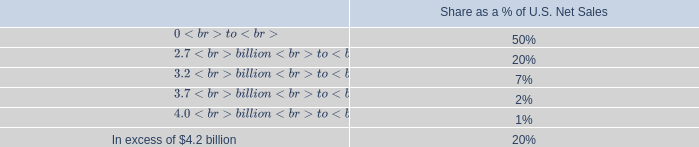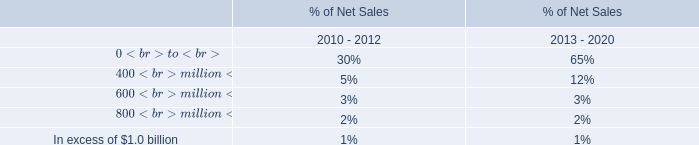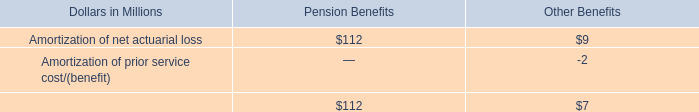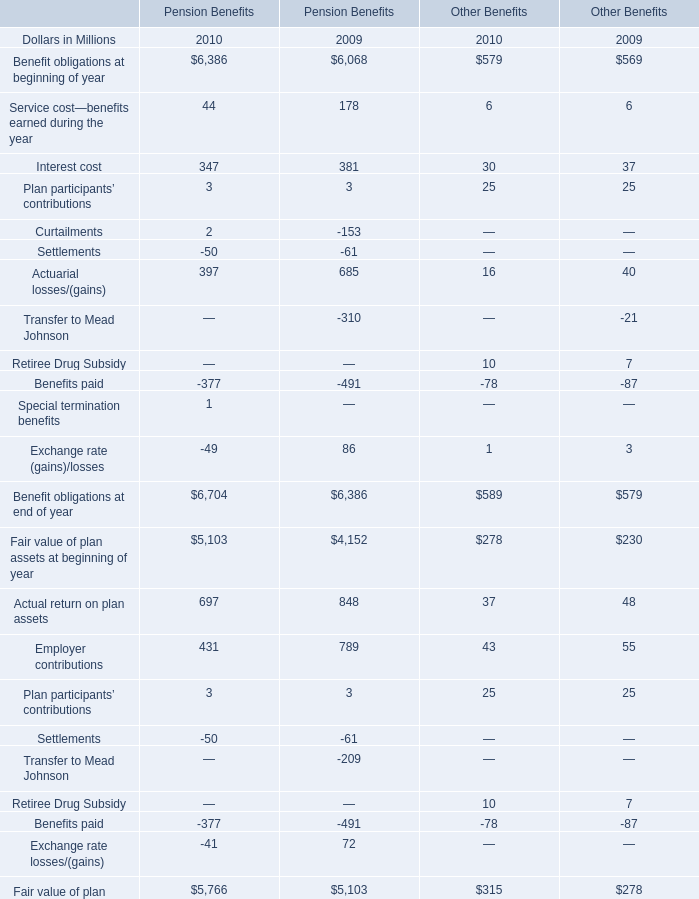In which years is Pension Benefits greater than Other Benefits (for Benefit obligations at beginning of year)? 
Answer: 2010. 